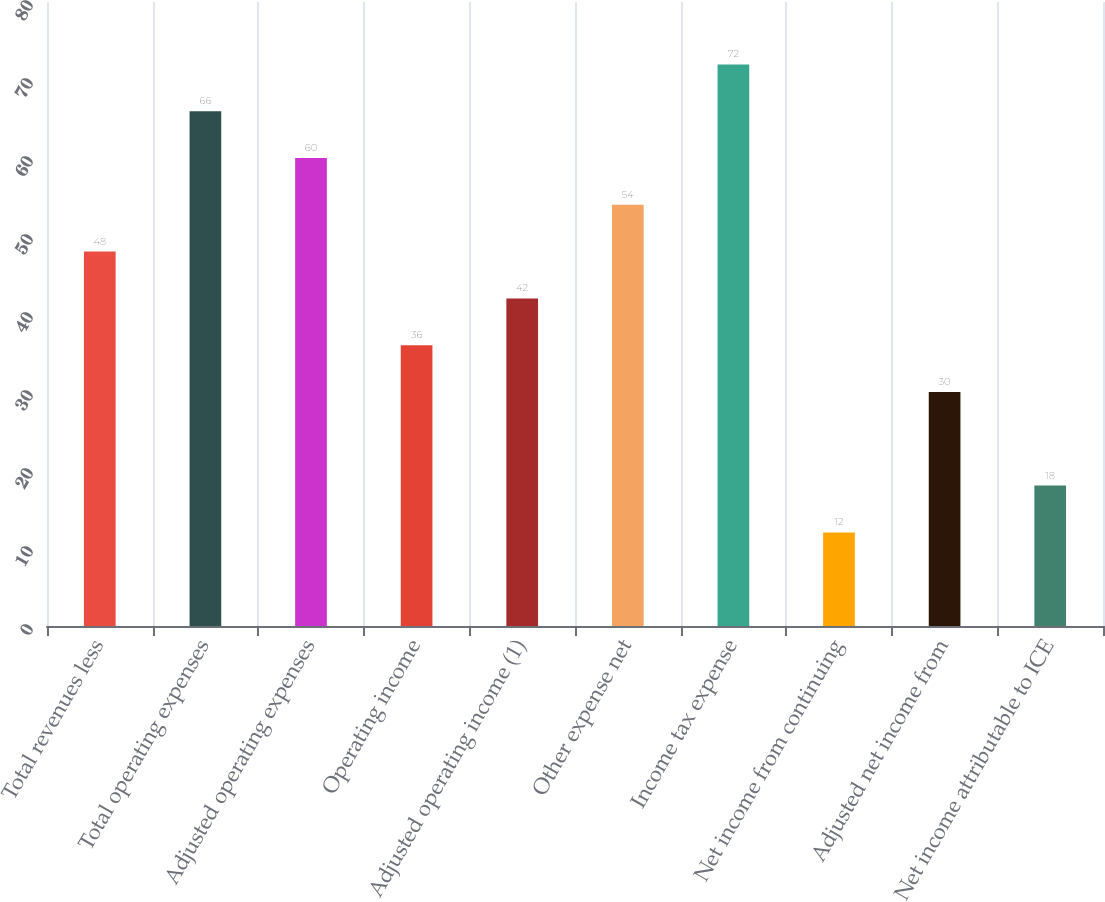Convert chart to OTSL. <chart><loc_0><loc_0><loc_500><loc_500><bar_chart><fcel>Total revenues less<fcel>Total operating expenses<fcel>Adjusted operating expenses<fcel>Operating income<fcel>Adjusted operating income (1)<fcel>Other expense net<fcel>Income tax expense<fcel>Net income from continuing<fcel>Adjusted net income from<fcel>Net income attributable to ICE<nl><fcel>48<fcel>66<fcel>60<fcel>36<fcel>42<fcel>54<fcel>72<fcel>12<fcel>30<fcel>18<nl></chart> 